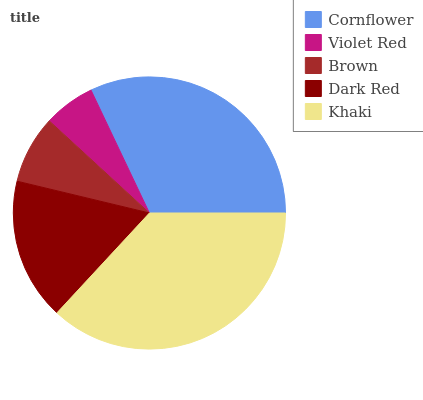Is Violet Red the minimum?
Answer yes or no. Yes. Is Khaki the maximum?
Answer yes or no. Yes. Is Brown the minimum?
Answer yes or no. No. Is Brown the maximum?
Answer yes or no. No. Is Brown greater than Violet Red?
Answer yes or no. Yes. Is Violet Red less than Brown?
Answer yes or no. Yes. Is Violet Red greater than Brown?
Answer yes or no. No. Is Brown less than Violet Red?
Answer yes or no. No. Is Dark Red the high median?
Answer yes or no. Yes. Is Dark Red the low median?
Answer yes or no. Yes. Is Khaki the high median?
Answer yes or no. No. Is Cornflower the low median?
Answer yes or no. No. 